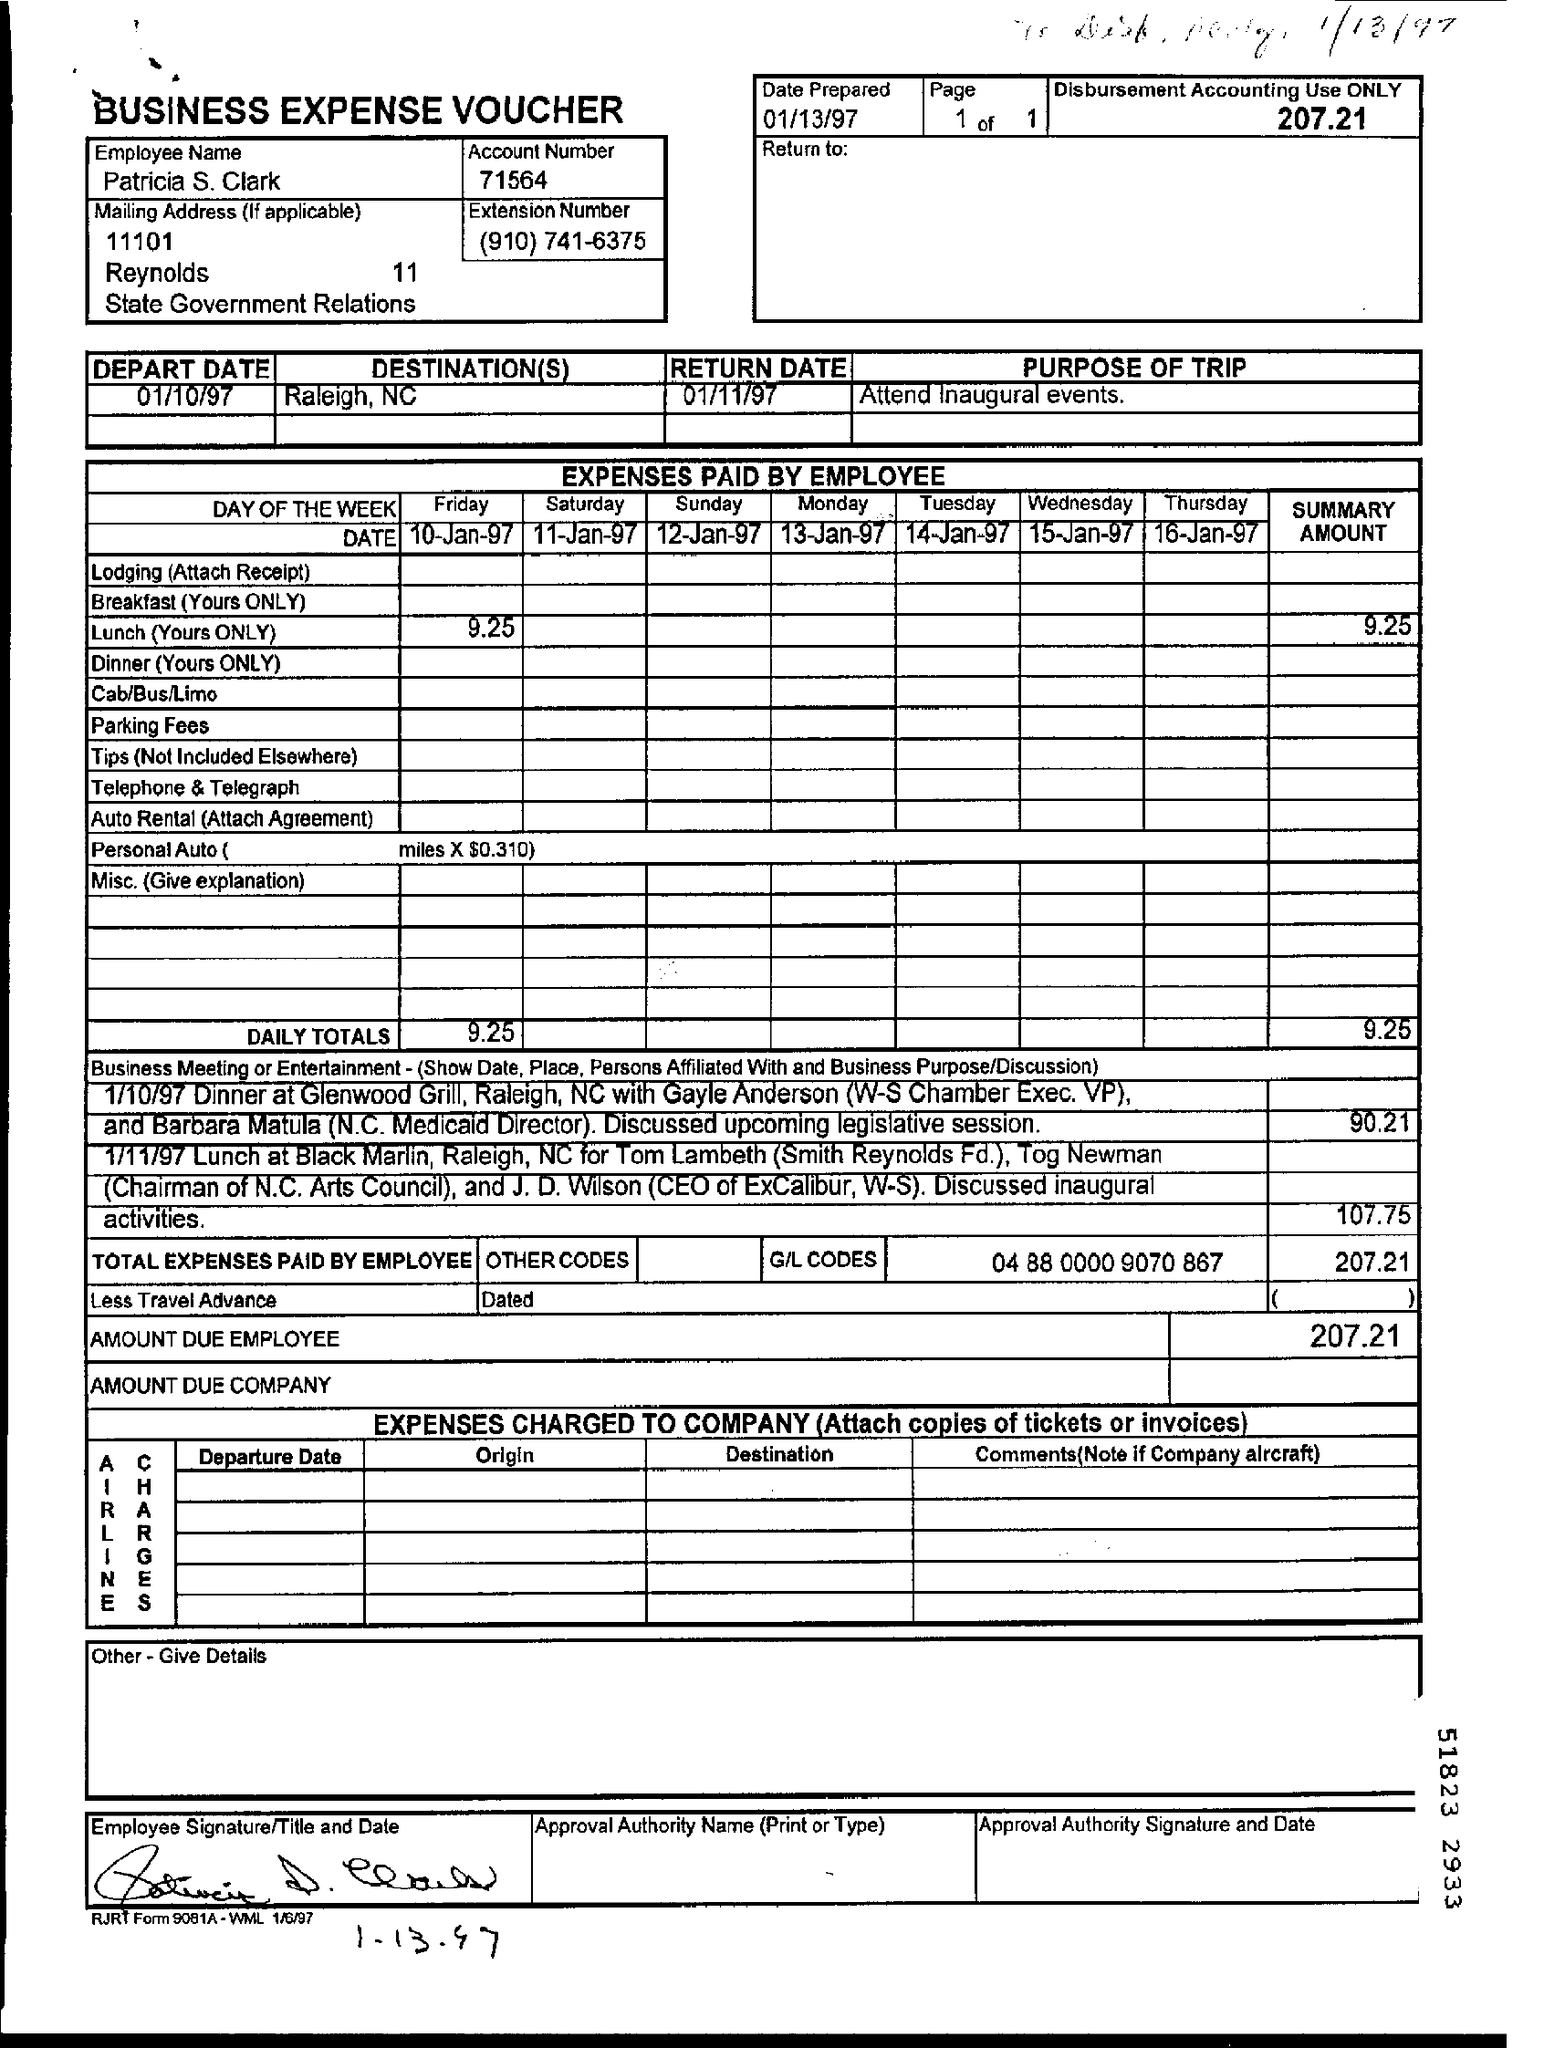What is the date prepared?
Provide a short and direct response. 01/13/97. What is the Employee Name ?
Provide a short and direct response. Patricia S. Clark. What is the purpose of trip ?
Your response must be concise. Attend inaugural events. What was the departure date ?
Provide a short and direct response. 01/10/97. What is the expense paid by employee on Friday?
Your response must be concise. 9.25. What is the amount due employee?
Your answer should be very brief. 207.21. How much did the lunch at Black Marlin cost ?
Your response must be concise. 107.75. How much did the Dinner at Glenwood grill cost ?
Keep it short and to the point. 90.21. What is the account number ?
Give a very brief answer. 71564. 